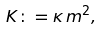<formula> <loc_0><loc_0><loc_500><loc_500>K \colon = \kappa \, m ^ { 2 } ,</formula> 